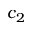Convert formula to latex. <formula><loc_0><loc_0><loc_500><loc_500>c _ { 2 }</formula> 